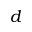Convert formula to latex. <formula><loc_0><loc_0><loc_500><loc_500>d</formula> 